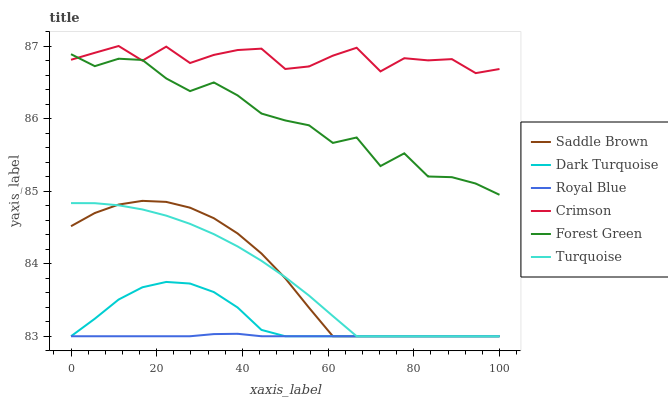Does Royal Blue have the minimum area under the curve?
Answer yes or no. Yes. Does Crimson have the maximum area under the curve?
Answer yes or no. Yes. Does Dark Turquoise have the minimum area under the curve?
Answer yes or no. No. Does Dark Turquoise have the maximum area under the curve?
Answer yes or no. No. Is Royal Blue the smoothest?
Answer yes or no. Yes. Is Forest Green the roughest?
Answer yes or no. Yes. Is Dark Turquoise the smoothest?
Answer yes or no. No. Is Dark Turquoise the roughest?
Answer yes or no. No. Does Turquoise have the lowest value?
Answer yes or no. Yes. Does Forest Green have the lowest value?
Answer yes or no. No. Does Crimson have the highest value?
Answer yes or no. Yes. Does Dark Turquoise have the highest value?
Answer yes or no. No. Is Turquoise less than Forest Green?
Answer yes or no. Yes. Is Crimson greater than Royal Blue?
Answer yes or no. Yes. Does Forest Green intersect Crimson?
Answer yes or no. Yes. Is Forest Green less than Crimson?
Answer yes or no. No. Is Forest Green greater than Crimson?
Answer yes or no. No. Does Turquoise intersect Forest Green?
Answer yes or no. No. 